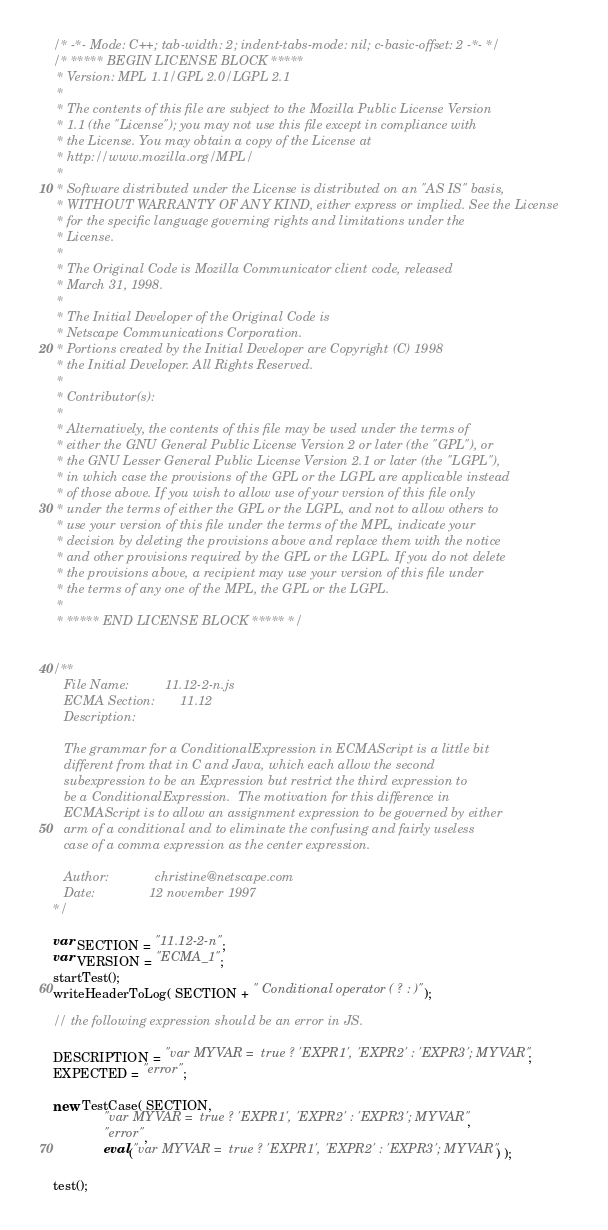<code> <loc_0><loc_0><loc_500><loc_500><_JavaScript_>/* -*- Mode: C++; tab-width: 2; indent-tabs-mode: nil; c-basic-offset: 2 -*- */
/* ***** BEGIN LICENSE BLOCK *****
 * Version: MPL 1.1/GPL 2.0/LGPL 2.1
 *
 * The contents of this file are subject to the Mozilla Public License Version
 * 1.1 (the "License"); you may not use this file except in compliance with
 * the License. You may obtain a copy of the License at
 * http://www.mozilla.org/MPL/
 *
 * Software distributed under the License is distributed on an "AS IS" basis,
 * WITHOUT WARRANTY OF ANY KIND, either express or implied. See the License
 * for the specific language governing rights and limitations under the
 * License.
 *
 * The Original Code is Mozilla Communicator client code, released
 * March 31, 1998.
 *
 * The Initial Developer of the Original Code is
 * Netscape Communications Corporation.
 * Portions created by the Initial Developer are Copyright (C) 1998
 * the Initial Developer. All Rights Reserved.
 *
 * Contributor(s):
 *
 * Alternatively, the contents of this file may be used under the terms of
 * either the GNU General Public License Version 2 or later (the "GPL"), or
 * the GNU Lesser General Public License Version 2.1 or later (the "LGPL"),
 * in which case the provisions of the GPL or the LGPL are applicable instead
 * of those above. If you wish to allow use of your version of this file only
 * under the terms of either the GPL or the LGPL, and not to allow others to
 * use your version of this file under the terms of the MPL, indicate your
 * decision by deleting the provisions above and replace them with the notice
 * and other provisions required by the GPL or the LGPL. If you do not delete
 * the provisions above, a recipient may use your version of this file under
 * the terms of any one of the MPL, the GPL or the LGPL.
 *
 * ***** END LICENSE BLOCK ***** */


/**
   File Name:          11.12-2-n.js
   ECMA Section:       11.12
   Description:

   The grammar for a ConditionalExpression in ECMAScript is a little bit
   different from that in C and Java, which each allow the second
   subexpression to be an Expression but restrict the third expression to
   be a ConditionalExpression.  The motivation for this difference in
   ECMAScript is to allow an assignment expression to be governed by either
   arm of a conditional and to eliminate the confusing and fairly useless
   case of a comma expression as the center expression.

   Author:             christine@netscape.com
   Date:               12 november 1997
*/

var SECTION = "11.12-2-n";
var VERSION = "ECMA_1";
startTest();
writeHeaderToLog( SECTION + " Conditional operator ( ? : )");

// the following expression should be an error in JS.

DESCRIPTION = "var MYVAR =  true ? 'EXPR1', 'EXPR2' : 'EXPR3'; MYVAR";
EXPECTED = "error";

new TestCase( SECTION,
              "var MYVAR =  true ? 'EXPR1', 'EXPR2' : 'EXPR3'; MYVAR",
              "error",
              eval("var MYVAR =  true ? 'EXPR1', 'EXPR2' : 'EXPR3'; MYVAR") );

test();

</code> 